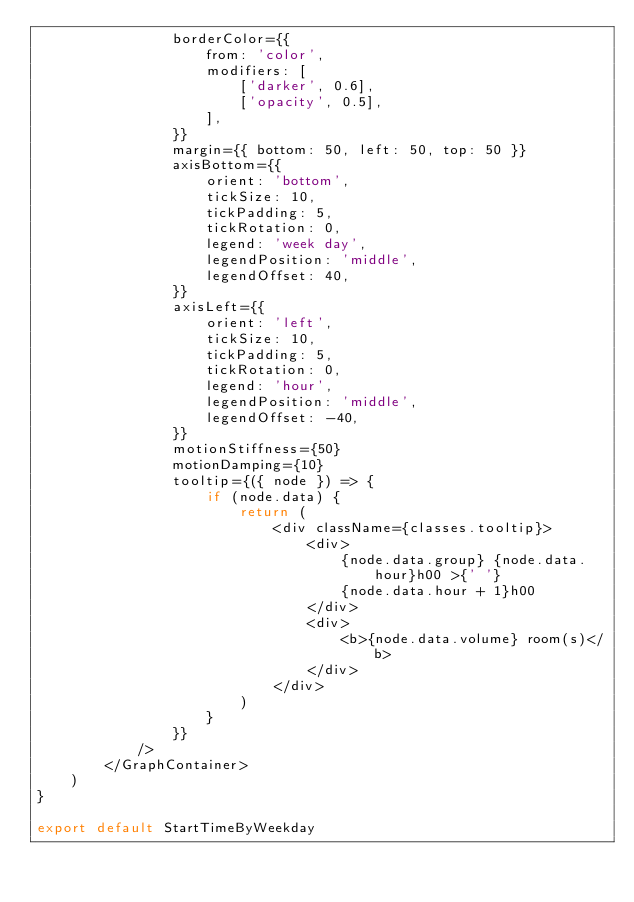Convert code to text. <code><loc_0><loc_0><loc_500><loc_500><_JavaScript_>                borderColor={{
                    from: 'color',
                    modifiers: [
                        ['darker', 0.6],
                        ['opacity', 0.5],
                    ],
                }}
                margin={{ bottom: 50, left: 50, top: 50 }}
                axisBottom={{
                    orient: 'bottom',
                    tickSize: 10,
                    tickPadding: 5,
                    tickRotation: 0,
                    legend: 'week day',
                    legendPosition: 'middle',
                    legendOffset: 40,
                }}
                axisLeft={{
                    orient: 'left',
                    tickSize: 10,
                    tickPadding: 5,
                    tickRotation: 0,
                    legend: 'hour',
                    legendPosition: 'middle',
                    legendOffset: -40,
                }}
                motionStiffness={50}
                motionDamping={10}
                tooltip={({ node }) => {
                    if (node.data) {
                        return (
                            <div className={classes.tooltip}>
                                <div>
                                    {node.data.group} {node.data.hour}h00 >{' '}
                                    {node.data.hour + 1}h00
                                </div>
                                <div>
                                    <b>{node.data.volume} room(s)</b>
                                </div>
                            </div>
                        )
                    }
                }}
            />
        </GraphContainer>
    )
}

export default StartTimeByWeekday
</code> 